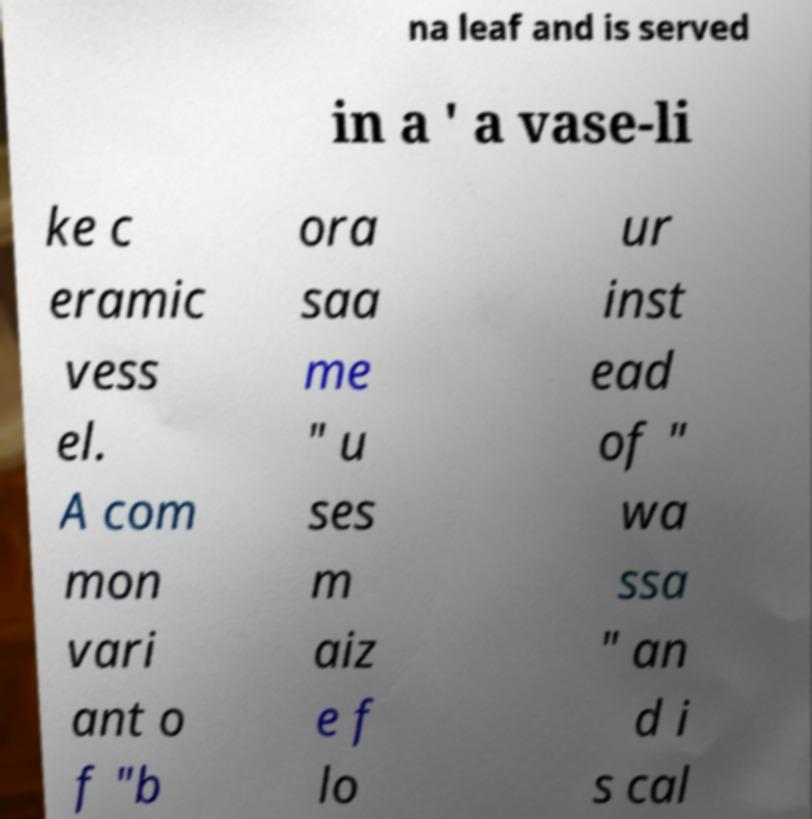Can you accurately transcribe the text from the provided image for me? na leaf and is served in a ' a vase-li ke c eramic vess el. A com mon vari ant o f "b ora saa me " u ses m aiz e f lo ur inst ead of " wa ssa " an d i s cal 